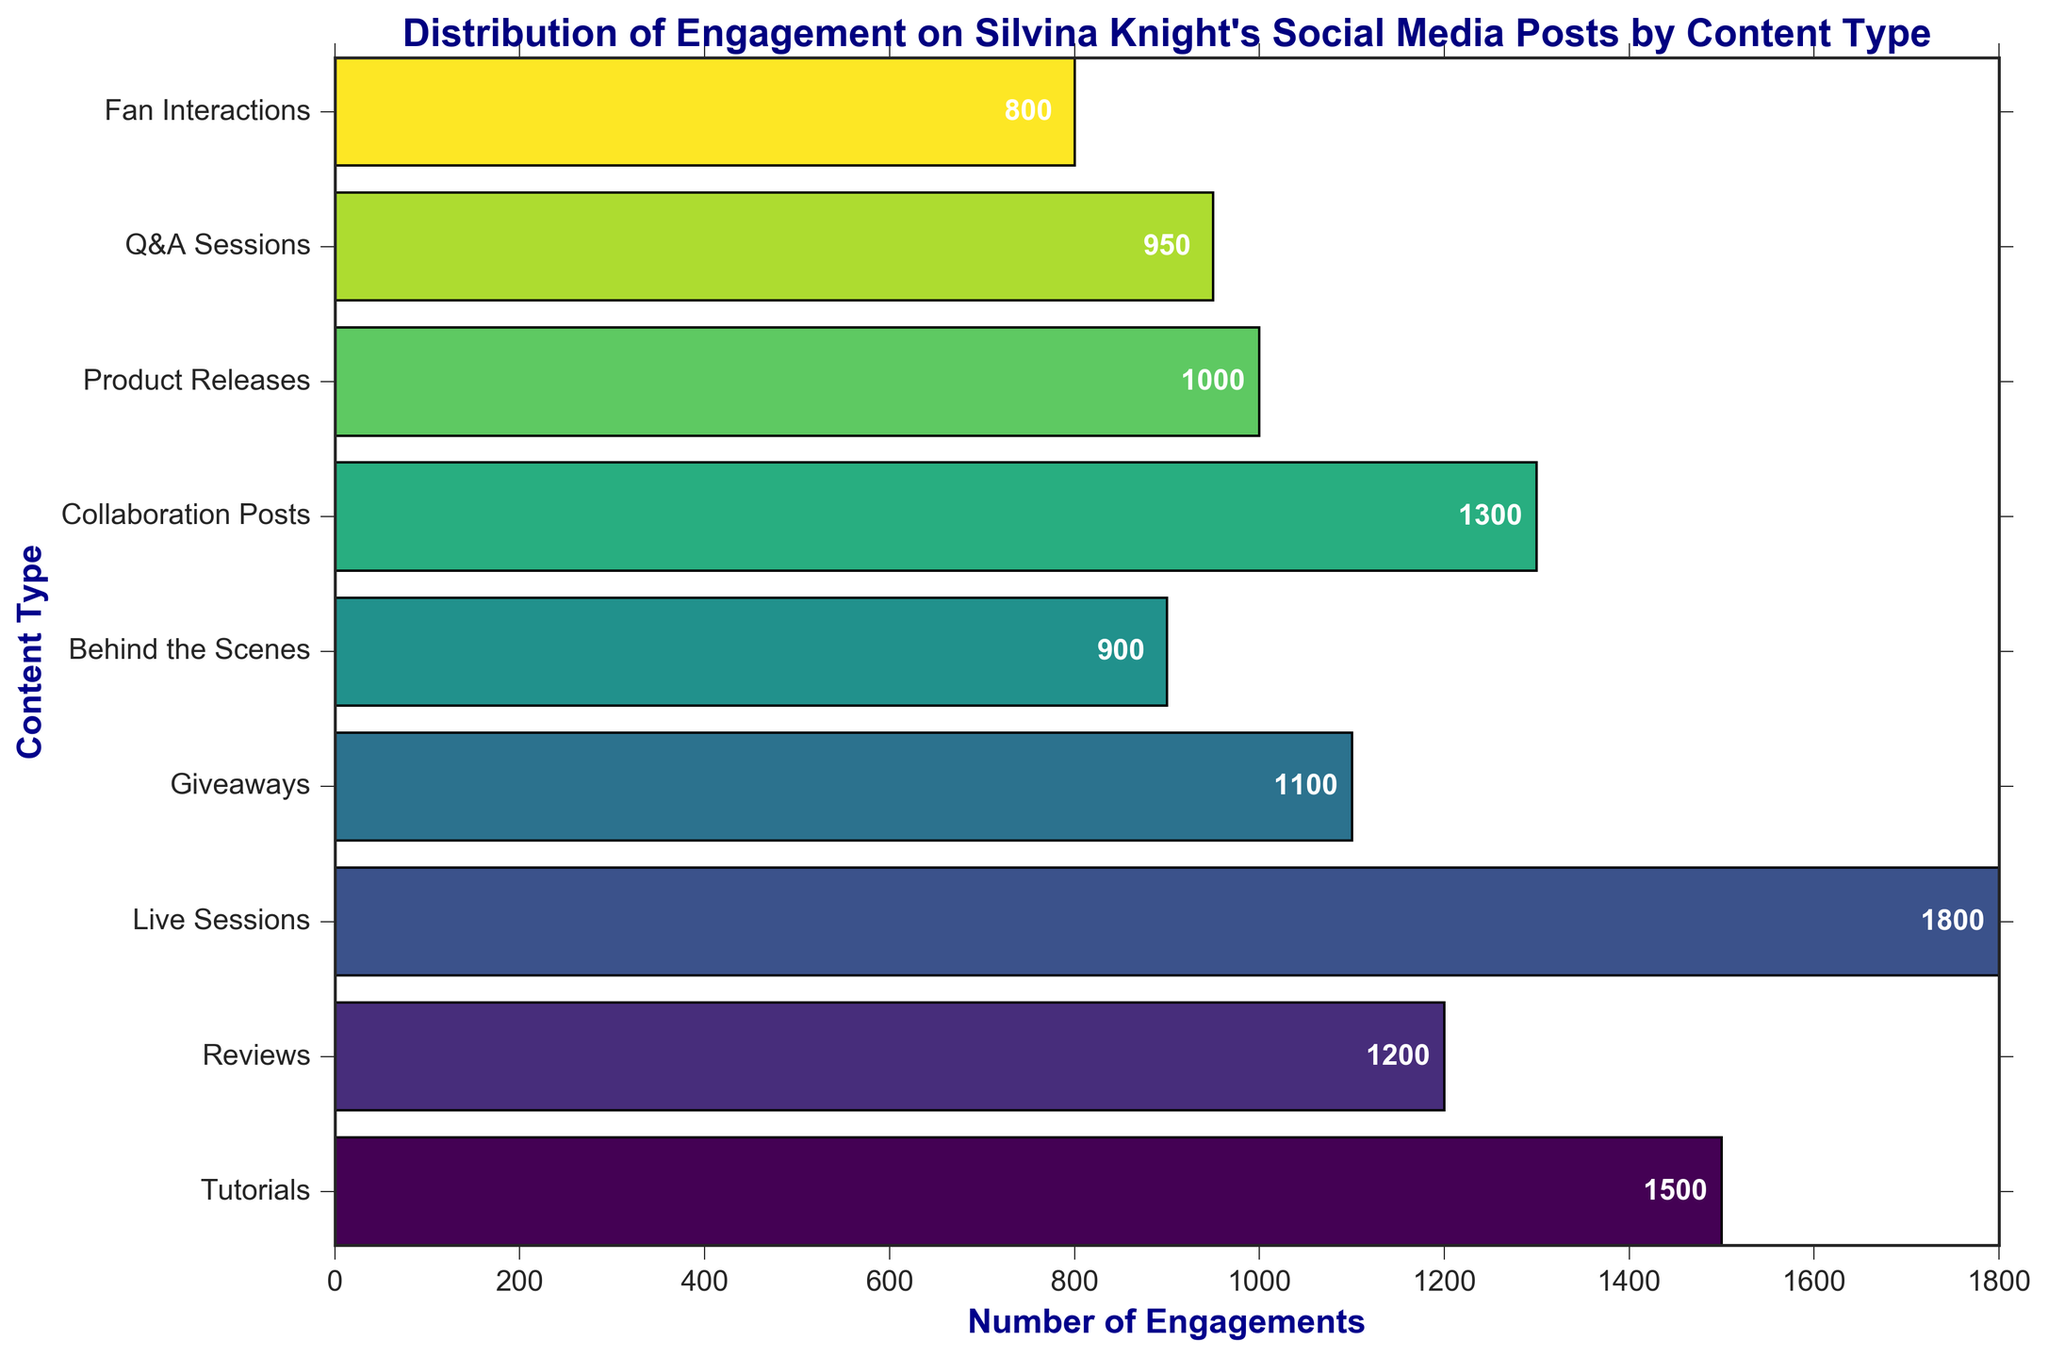Which content type has the highest number of engagements? Look at the bar chart and identify the bar with the greatest length. The bar for "Live Sessions" extends to 1800 engagements, which is the highest among all the content types.
Answer: Live Sessions How many more engagements do Live Sessions have compared to Tutorials? The engagements for Live Sessions are 1800 and for Tutorials are 1500. Subtract the number of engagements for Tutorials from the number for Live Sessions: 1800 - 1500 = 300.
Answer: 300 What is the average number of engagements across all content types? Sum all the engagements: 1500 + 1200 + 1800 + 1100 + 900 + 1300 + 1000 + 950 + 800 = 10650. There are 9 content types, so divide the total engagements by 9: 10650 / 9 ≈ 1183.33.
Answer: Approximately 1183.33 Which content types have fewer than 1000 engagements? From the bar chart, the bars for "Behind the Scenes," "Q&A Sessions," and "Fan Interactions" do not reach the 1000 mark.
Answer: Behind the Scenes, Q&A Sessions, Fan Interactions What is the total number of engagements for Reviews and Collaboration Posts combined? The engagements for Reviews are 1200, and for Collaboration Posts are 1300. Add them together: 1200 + 1300 = 2500.
Answer: 2500 Are there more engagements for Product Releases or Giveaways? Compare the lengths of the bars for "Product Releases" and "Giveaways." The bar for Giveaways is longer, corresponding to 1100 engagements, while Product Releases have 1000 engagements.
Answer: Giveaways How does the engagement for Fan Interactions compare to Q&A Sessions? The engagement for Fan Interactions is 800, while the engagement for Q&A Sessions is 950. 800 is less than 950.
Answer: Fan Interactions has less What is the difference in engagements between the highest (Live Sessions) and lowest (Fan Interactions) content types? The highest engagement is for Live Sessions with 1800, and the lowest is for Fan Interactions with 800. Subtract the lowest from the highest: 1800 - 800 = 1000.
Answer: 1000 Which content types have engagement values between 900 and 1300? From the chart, the bars for Reviews (1200), Giveaways (1100), and Collaboration Posts (1300) fit within the range of 900 to 1300.
Answer: Reviews, Giveaways, Collaboration Posts If Silvina wants to boost her engagement for content types with fewer than 1000 engagements to at least 1000, how many more engagements does she need in total? Identify the content types with fewer than 1000 engagements: Behind the Scenes (900), Product Releases (1000), Q&A Sessions (950), Fan Interactions (800). Calculate the additional engagements needed: Behind the Scenes needs 1000 - 900 = 100, Q&A Sessions needs 1000 - 950 = 50, Fan Interactions need 1000 - 800 = 200. Add these together: 100 + 50 + 200 = 350.
Answer: 350 